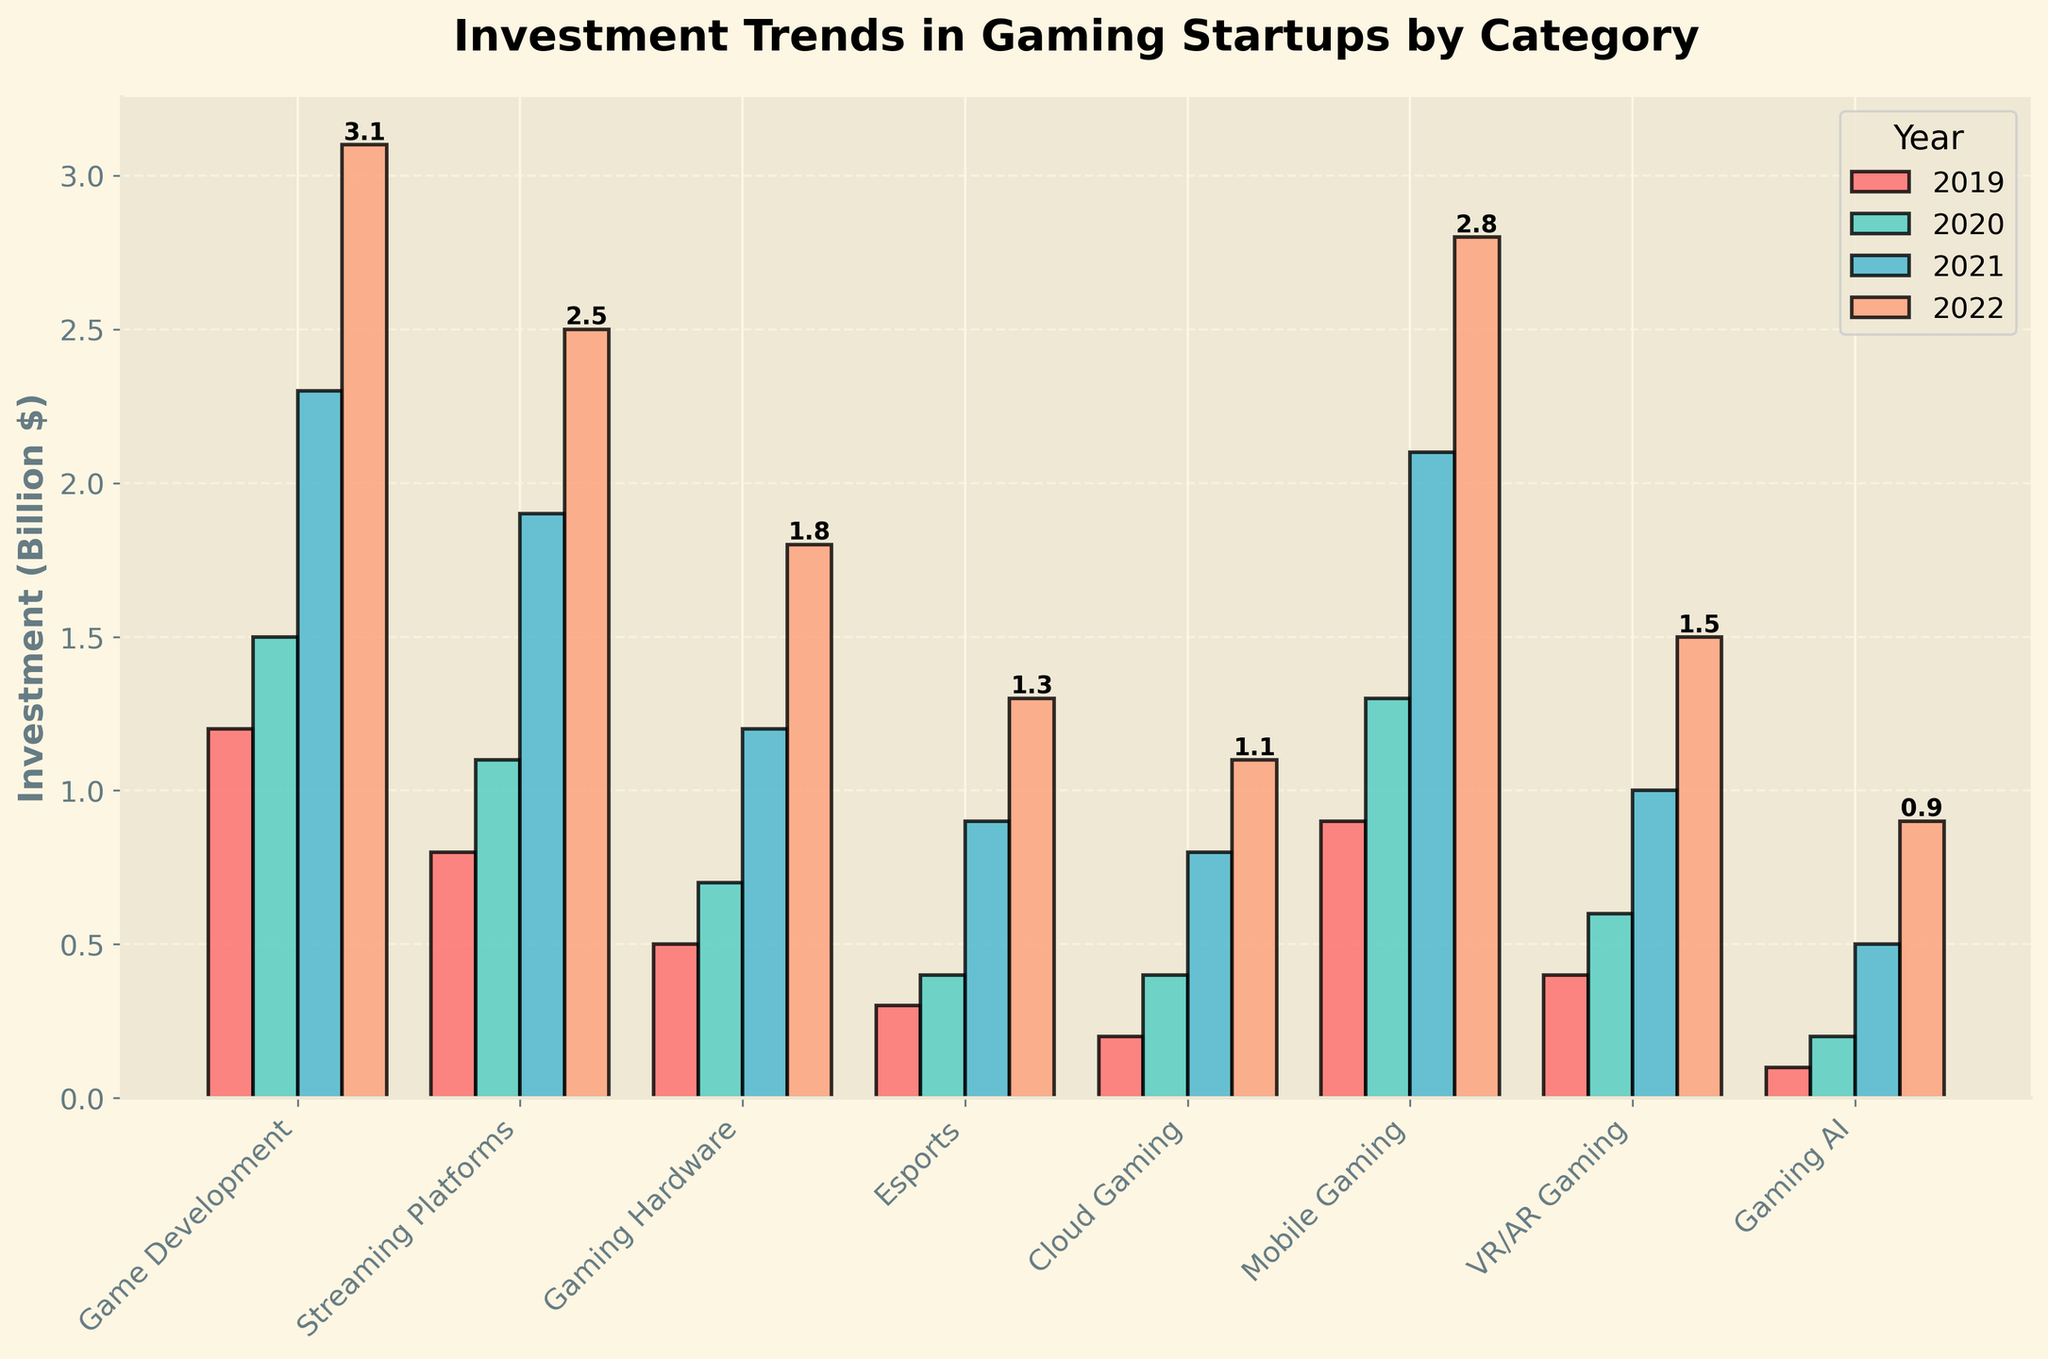What's the total investment in VR/AR Gaming over the years? To calculate the total investment in VR/AR Gaming, sum the investment amounts from each year: 2019 (0.4 billion) + 2020 (0.6 billion) + 2021 (1.0 billion) + 2022 (1.5 billion) = 3.5 billion.
Answer: 3.5 billion Which category had the highest investment in 2022? By observing the graph, we can see the height of the bars for 2022. The category with the tallest bar for 2022 is Game Development with an investment of 3.1 billion.
Answer: Game Development Compare the investments in Game Development and Cloud Gaming in 2020. Which had more and by how much? Check the heights of the bars in 2020 for both categories: Game Development (1.5 billion) and Cloud Gaming (0.4 billion). Subtract the smaller investment from the larger: 1.5 billion - 0.4 billion = 1.1 billion. Game Development had 1.1 billion more investment than Cloud Gaming in 2020.
Answer: Game Development by 1.1 billion By how much did the investment in Streaming Platforms increase from 2019 to 2022? Calculate the increase by subtracting the 2019 investment from the 2022 investment for Streaming Platforms: 2.5 billion (2022) - 0.8 billion (2019) = 1.7 billion.
Answer: 1.7 billion What is the average investment in Mobile Gaming across all years? Sum the investments in Mobile Gaming for each year and divide by the number of years: (0.9 billion + 1.3 billion + 2.1 billion + 2.8 billion) / 4 = 7.1 billion / 4 = 1.775 billion.
Answer: 1.775 billion Which category saw the smallest investment increase from 2019 to 2022? Calculate the increase in investment for each category from 2019 to 2022: 
- Game Development: 3.1 - 1.2 = 1.9 billion
- Streaming Platforms: 2.5 - 0.8 = 1.7 billion
- Gaming Hardware: 1.8 - 0.5 = 1.3 billion
- Esports: 1.3 - 0.3 = 1.0 billion
- Cloud Gaming: 1.1 - 0.2 = 0.9 billion
- Mobile Gaming: 2.8 - 0.9 = 1.9 billion
- VR/AR Gaming: 1.5 - 0.4 = 1.1 billion
- Gaming AI: 0.9 - 0.1 = 0.8 billion
 
Gaming AI had the smallest increase of 0.8 billion.
Answer: Gaming AI What's the ratio of investment in Game Development to Gaming Hardware in 2021? Check the investments for both categories in 2021: Game Development (2.3 billion) and Gaming Hardware (1.2 billion). The ratio is 2.3 / 1.2 ≈ 1.92.
Answer: 1.92 How much more was invested in Mobile Gaming compared to Esports in 2022? By referring to the 2022 investments for both categories: Mobile Gaming (2.8 billion) and Esports (1.3 billion). The difference is 2.8 - 1.3 = 1.5 billion.
Answer: 1.5 billion 